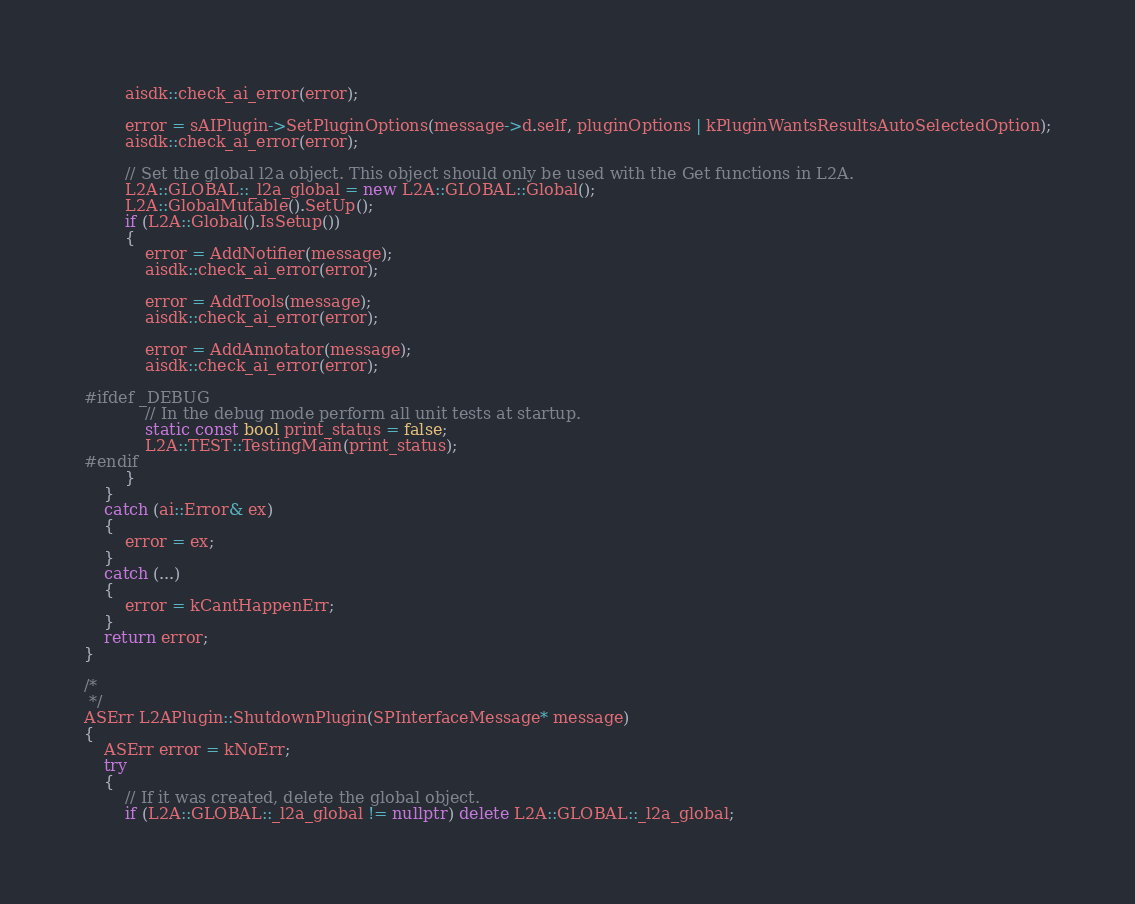Convert code to text. <code><loc_0><loc_0><loc_500><loc_500><_C++_>        aisdk::check_ai_error(error);

        error = sAIPlugin->SetPluginOptions(message->d.self, pluginOptions | kPluginWantsResultsAutoSelectedOption);
        aisdk::check_ai_error(error);

        // Set the global l2a object. This object should only be used with the Get functions in L2A.
        L2A::GLOBAL::_l2a_global = new L2A::GLOBAL::Global();
        L2A::GlobalMutable().SetUp();
        if (L2A::Global().IsSetup())
        {
            error = AddNotifier(message);
            aisdk::check_ai_error(error);

            error = AddTools(message);
            aisdk::check_ai_error(error);

            error = AddAnnotator(message);
            aisdk::check_ai_error(error);

#ifdef _DEBUG
            // In the debug mode perform all unit tests at startup.
            static const bool print_status = false;
            L2A::TEST::TestingMain(print_status);
#endif
        }
    }
    catch (ai::Error& ex)
    {
        error = ex;
    }
    catch (...)
    {
        error = kCantHappenErr;
    }
    return error;
}

/*
 */
ASErr L2APlugin::ShutdownPlugin(SPInterfaceMessage* message)
{
    ASErr error = kNoErr;
    try
    {
        // If it was created, delete the global object.
        if (L2A::GLOBAL::_l2a_global != nullptr) delete L2A::GLOBAL::_l2a_global;
</code> 